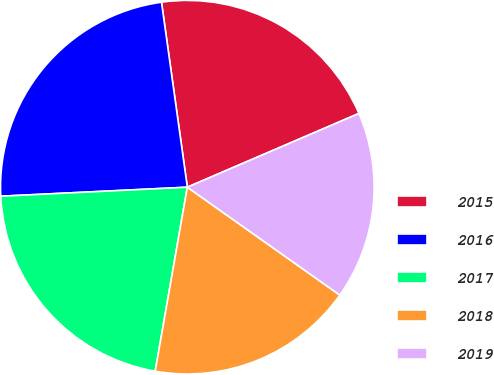<chart> <loc_0><loc_0><loc_500><loc_500><pie_chart><fcel>2015<fcel>2016<fcel>2017<fcel>2018<fcel>2019<nl><fcel>20.75%<fcel>23.56%<fcel>21.48%<fcel>17.95%<fcel>16.26%<nl></chart> 